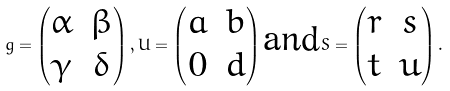<formula> <loc_0><loc_0><loc_500><loc_500>g = \begin{pmatrix} \alpha & \beta \\ \gamma & \delta \end{pmatrix} , U = \begin{pmatrix} a & b \\ 0 & d \end{pmatrix} \text {and} S = \begin{pmatrix} r & s \\ t & u \end{pmatrix} .</formula> 